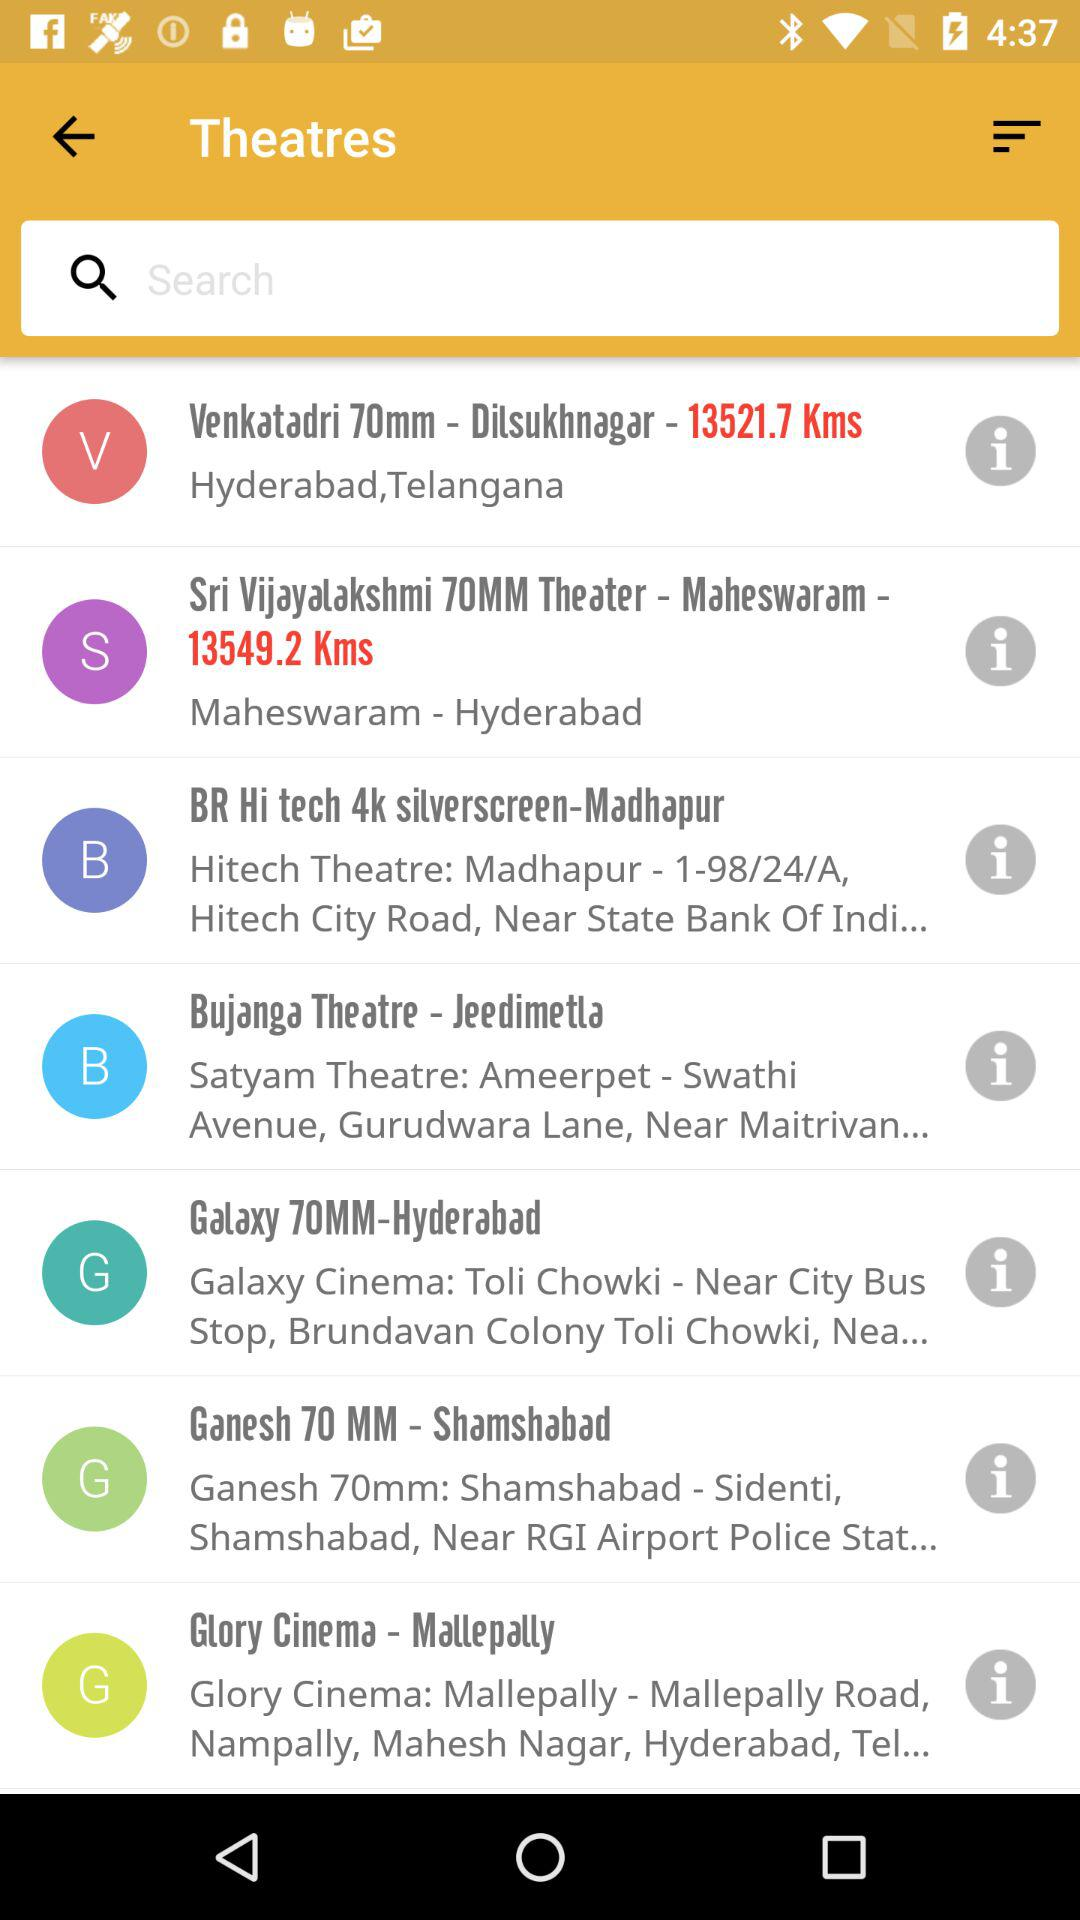What is the distance between Venkatadri to Dilsukhnagar?
When the provided information is insufficient, respond with <no answer>. <no answer> 